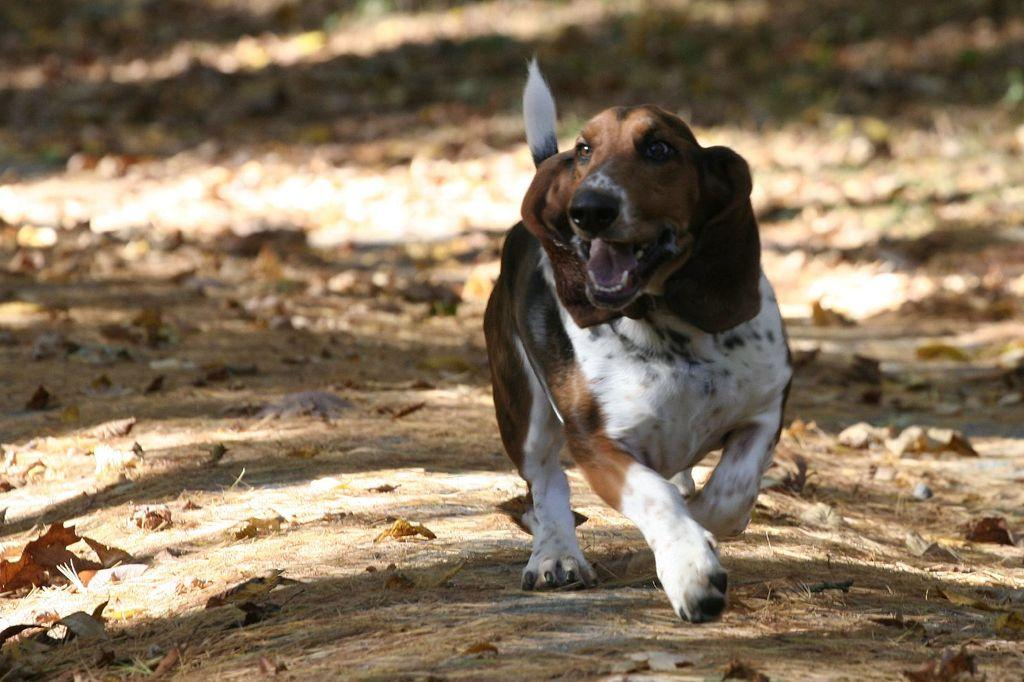What type of animal is present in the image? There is a dog in the image. What is covering the ground in the image? The ground is covered with dried leaves. How many feet does the yoke have in the image? There is no yoke present in the image, so it is not possible to determine the number of feet it might have. 